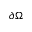Convert formula to latex. <formula><loc_0><loc_0><loc_500><loc_500>\partial \Omega</formula> 